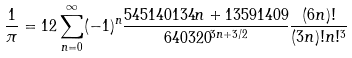<formula> <loc_0><loc_0><loc_500><loc_500>\frac { 1 } { \pi } = 1 2 \sum _ { n = 0 } ^ { \infty } ( - 1 ) ^ { n } \frac { 5 4 5 1 4 0 1 3 4 n + 1 3 5 9 1 4 0 9 } { 6 4 0 3 2 0 ^ { 3 n + 3 / 2 } } \frac { ( 6 n ) ! } { ( 3 n ) ! n ! ^ { 3 } }</formula> 